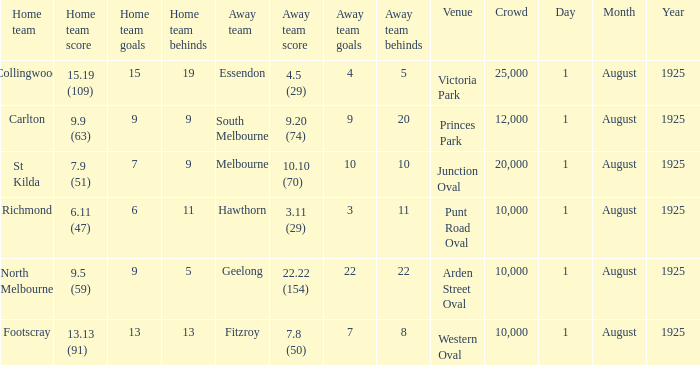What was the away team's score at the match played at The Western Oval? 7.8 (50). 